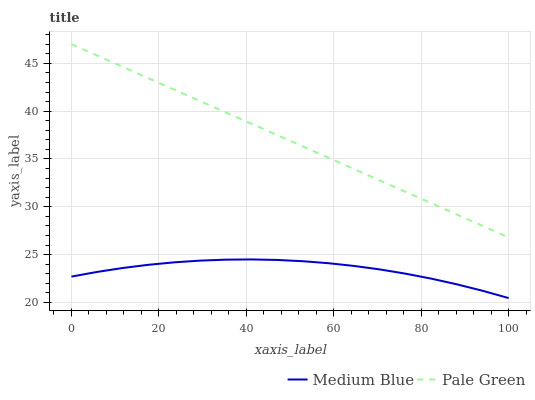Does Medium Blue have the minimum area under the curve?
Answer yes or no. Yes. Does Pale Green have the maximum area under the curve?
Answer yes or no. Yes. Does Medium Blue have the maximum area under the curve?
Answer yes or no. No. Is Pale Green the smoothest?
Answer yes or no. Yes. Is Medium Blue the roughest?
Answer yes or no. Yes. Is Medium Blue the smoothest?
Answer yes or no. No. Does Medium Blue have the lowest value?
Answer yes or no. Yes. Does Pale Green have the highest value?
Answer yes or no. Yes. Does Medium Blue have the highest value?
Answer yes or no. No. Is Medium Blue less than Pale Green?
Answer yes or no. Yes. Is Pale Green greater than Medium Blue?
Answer yes or no. Yes. Does Medium Blue intersect Pale Green?
Answer yes or no. No. 